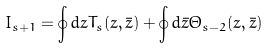<formula> <loc_0><loc_0><loc_500><loc_500>I _ { s + 1 } = \oint d z T _ { s } ( z , \bar { z } ) + \oint d \bar { z } \Theta _ { s - 2 } ( z , \bar { z } )</formula> 